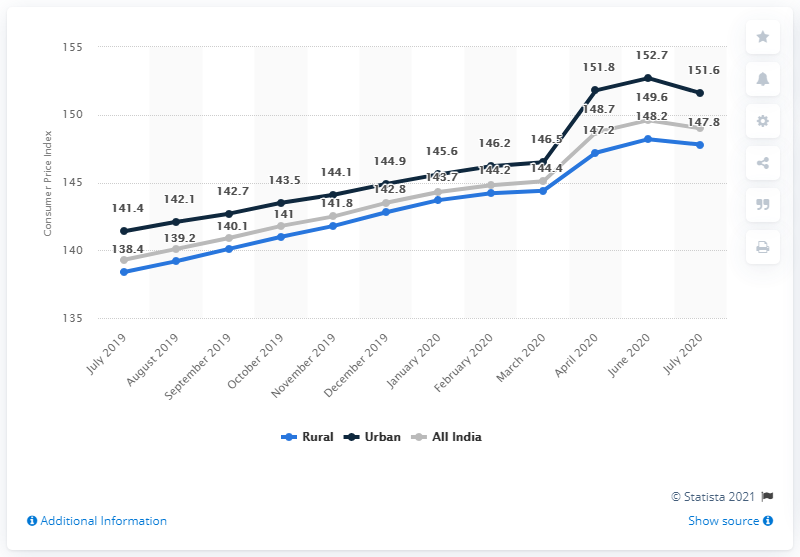Draw attention to some important aspects in this diagram. The average for April 2020 is 149.233333... The peak of all India was in June 2020. 